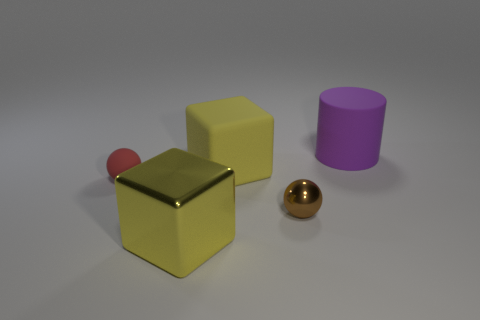Is the small brown thing made of the same material as the big purple cylinder?
Offer a very short reply. No. What color is the metallic block that is the same size as the rubber cylinder?
Provide a succinct answer. Yellow. There is a big thing that is behind the yellow metal thing and to the left of the small brown object; what color is it?
Keep it short and to the point. Yellow. The thing that is the same color as the metal cube is what size?
Ensure brevity in your answer.  Large. There is a thing that is the same color as the metal block; what is its shape?
Provide a succinct answer. Cube. There is a yellow block that is in front of the small brown shiny thing in front of the yellow block that is behind the red thing; how big is it?
Give a very brief answer. Large. What is the big purple object made of?
Your answer should be compact. Rubber. Do the small red thing and the large block behind the tiny brown sphere have the same material?
Give a very brief answer. Yes. Are there any other things of the same color as the shiny sphere?
Your answer should be compact. No. There is a big object in front of the big yellow thing that is behind the small brown metallic thing; are there any big metal cubes in front of it?
Keep it short and to the point. No. 